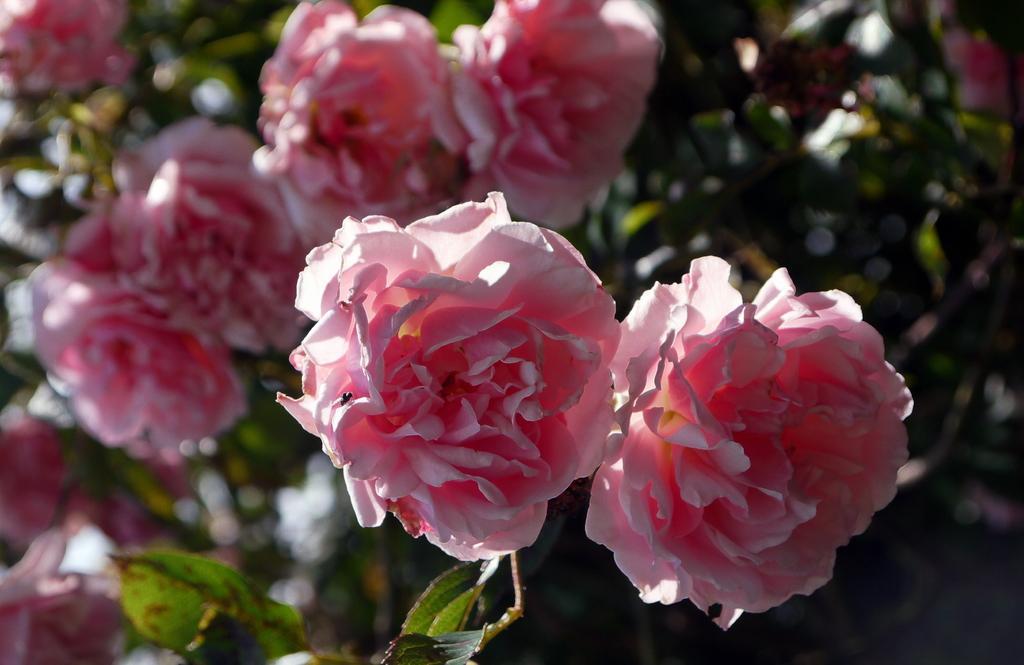Could you give a brief overview of what you see in this image? In this picture, we see the plants or trees which have flowers. These flowers are in pink color. In the background, we see the trees. This picture is blurred in the background. 